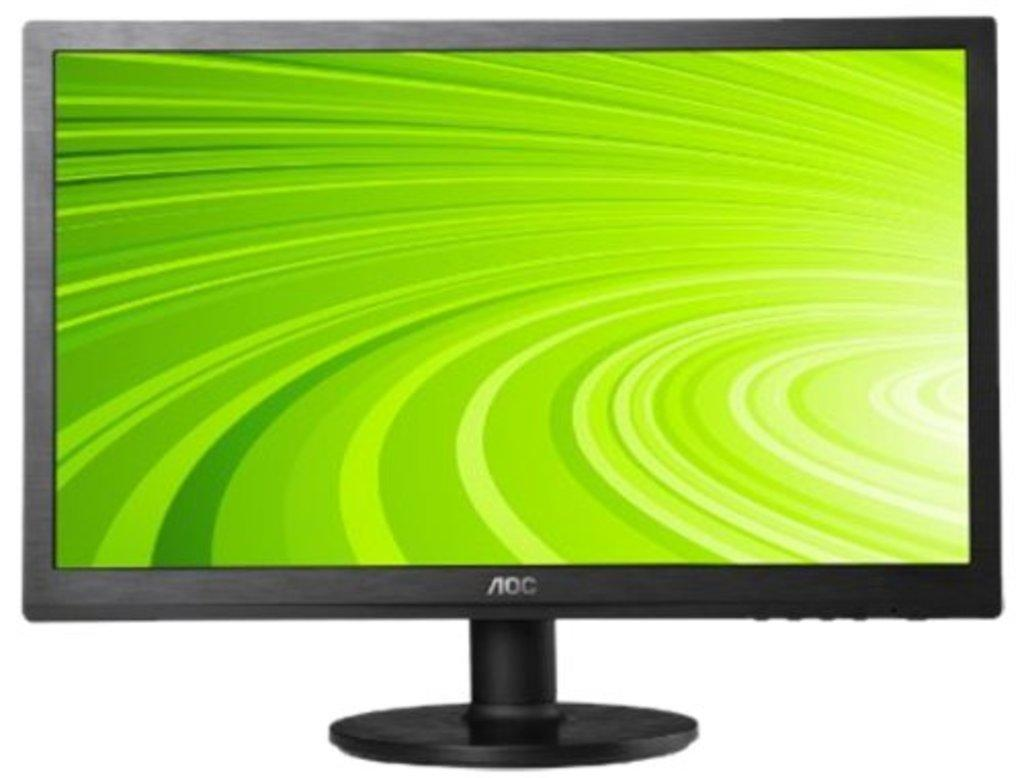<image>
Give a short and clear explanation of the subsequent image. An AOC brand monitor displays a green screen. 